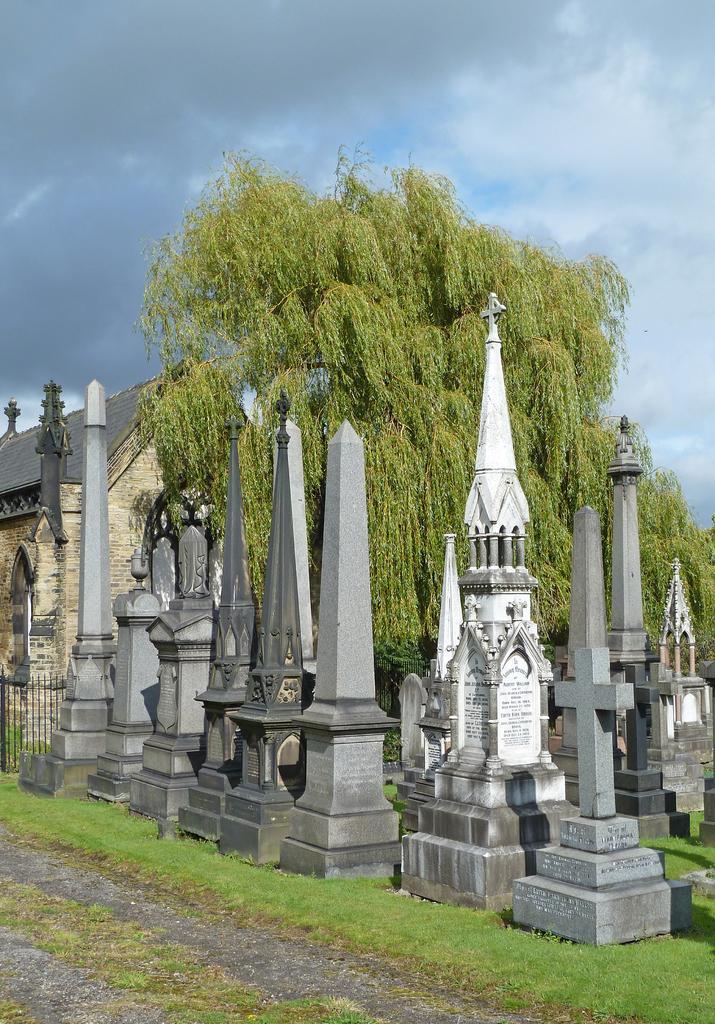Could you give a brief overview of what you see in this image? In this image, we can see monument stones. There is a tree in the middle of the image. There is a roof house on the left side of the image. There are clouds in the sky. At the bottom of the image, we can see some grass. 